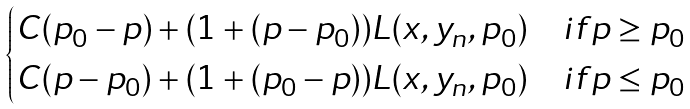<formula> <loc_0><loc_0><loc_500><loc_500>\begin{cases} C ( p _ { 0 } - p ) + ( 1 + ( p - p _ { 0 } ) ) L ( x , y _ { n } , p _ { 0 } ) & i f p \geq p _ { 0 } \\ C ( p - p _ { 0 } ) + ( 1 + ( p _ { 0 } - p ) ) L ( x , y _ { n } , p _ { 0 } ) & i f p \leq p _ { 0 } \end{cases}</formula> 